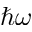Convert formula to latex. <formula><loc_0><loc_0><loc_500><loc_500>\hbar { \omega }</formula> 